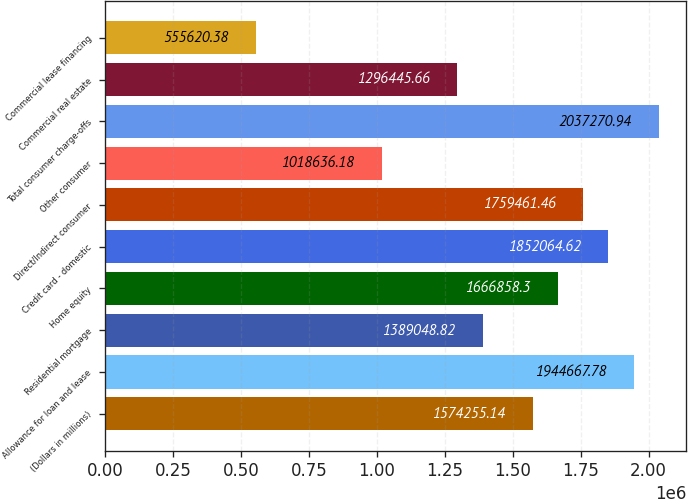<chart> <loc_0><loc_0><loc_500><loc_500><bar_chart><fcel>(Dollars in millions)<fcel>Allowance for loan and lease<fcel>Residential mortgage<fcel>Home equity<fcel>Credit card - domestic<fcel>Direct/Indirect consumer<fcel>Other consumer<fcel>Total consumer charge-offs<fcel>Commercial real estate<fcel>Commercial lease financing<nl><fcel>1.57426e+06<fcel>1.94467e+06<fcel>1.38905e+06<fcel>1.66686e+06<fcel>1.85206e+06<fcel>1.75946e+06<fcel>1.01864e+06<fcel>2.03727e+06<fcel>1.29645e+06<fcel>555620<nl></chart> 